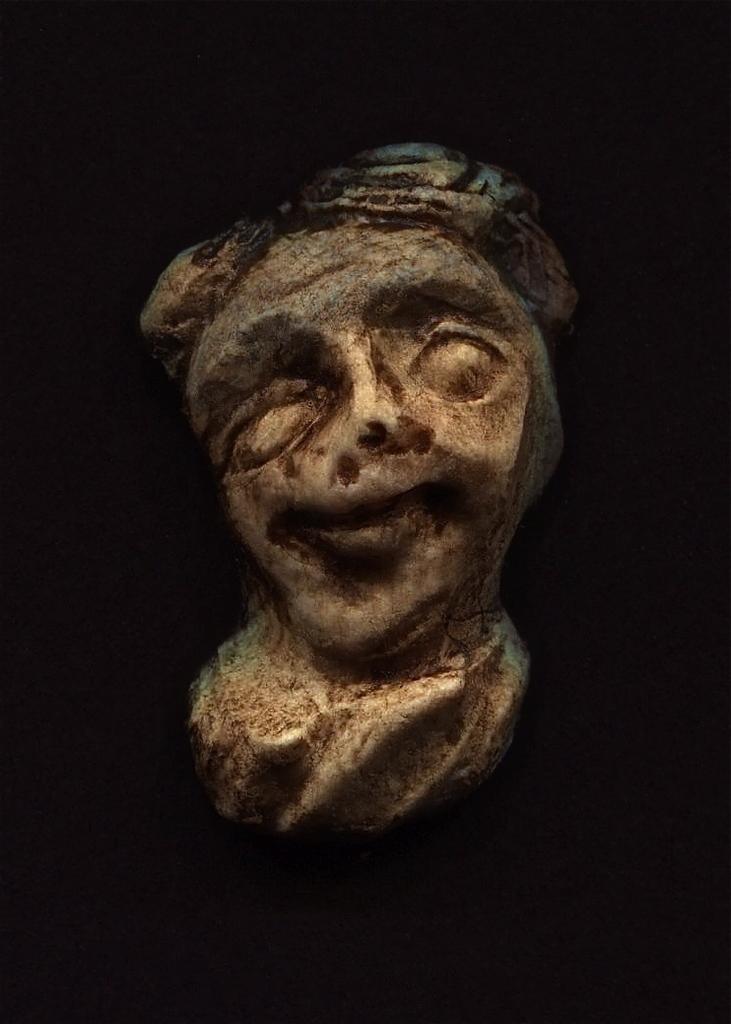Describe this image in one or two sentences. This image the background is dark. In the middle of the image there is a sculpture. 